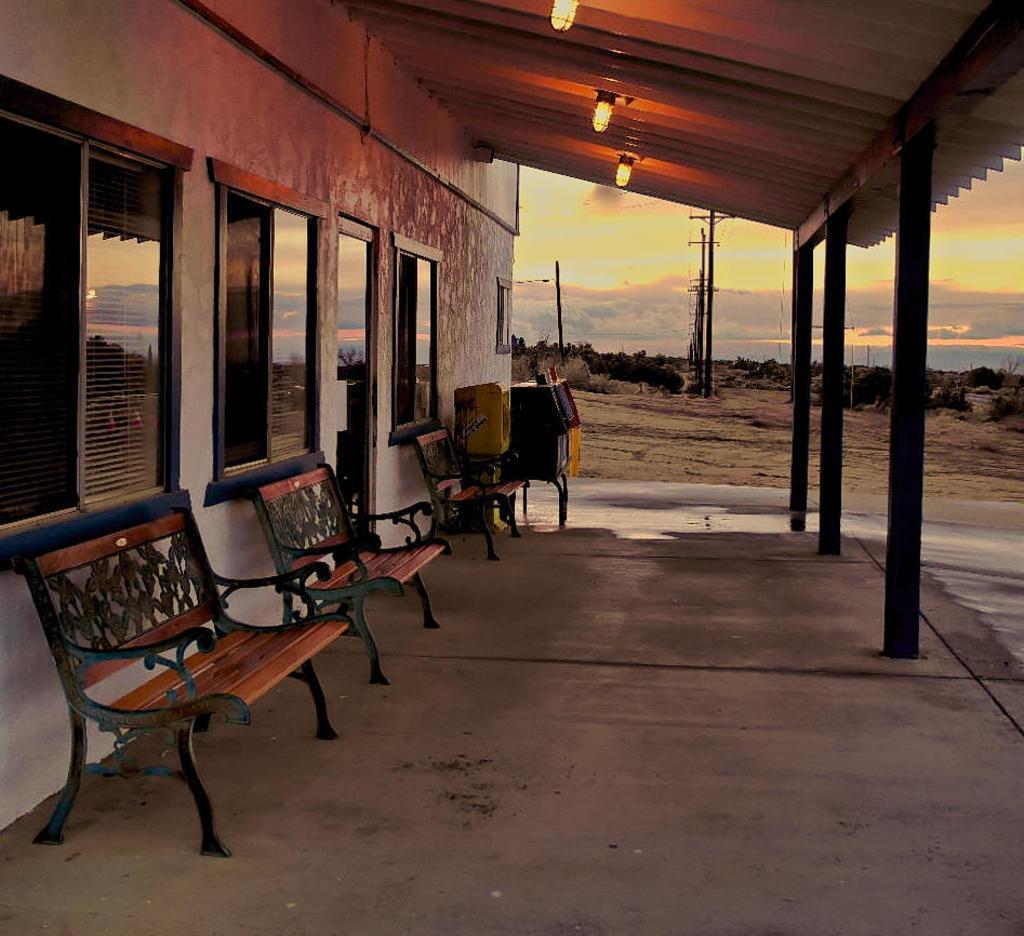Please provide a concise description of this image. In this picture we can see a building with windows, benches, pillars, trees, lights, poles and in the background we can see the sky with clouds. 